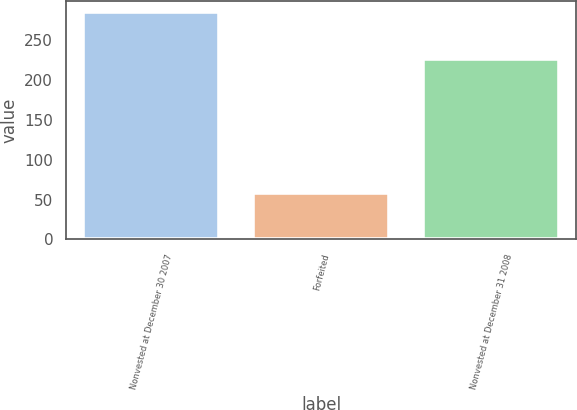<chart> <loc_0><loc_0><loc_500><loc_500><bar_chart><fcel>Nonvested at December 30 2007<fcel>Forfeited<fcel>Nonvested at December 31 2008<nl><fcel>285<fcel>58<fcel>227<nl></chart> 